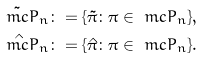Convert formula to latex. <formula><loc_0><loc_0><loc_500><loc_500>\tilde { \ m c P } _ { n } & \colon = \{ \tilde { \pi } \colon \pi \in \ m c P _ { n } \} , \\ \hat { \ m c P } _ { n } & \colon = \{ \hat { \pi } \colon \pi \in \ m c P _ { n } \} .</formula> 